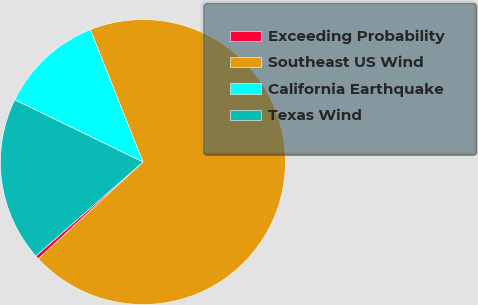Convert chart. <chart><loc_0><loc_0><loc_500><loc_500><pie_chart><fcel>Exceeding Probability<fcel>Southeast US Wind<fcel>California Earthquake<fcel>Texas Wind<nl><fcel>0.42%<fcel>69.14%<fcel>11.79%<fcel>18.66%<nl></chart> 